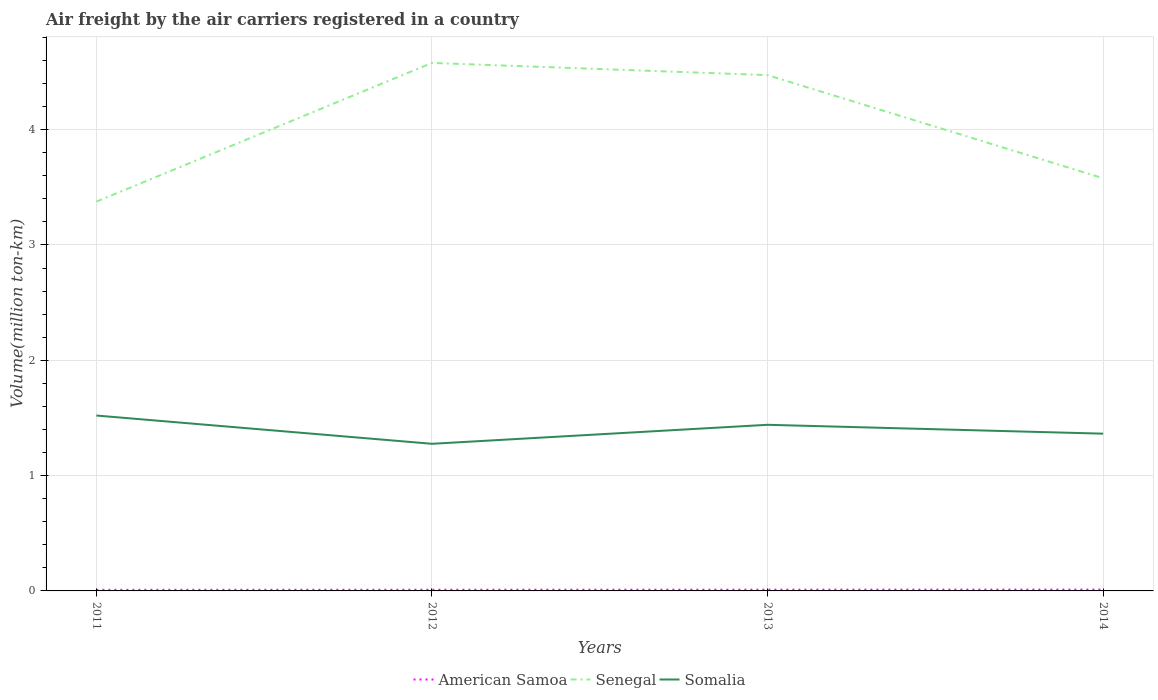How many different coloured lines are there?
Your response must be concise. 3. Does the line corresponding to American Samoa intersect with the line corresponding to Somalia?
Provide a succinct answer. No. Is the number of lines equal to the number of legend labels?
Give a very brief answer. Yes. Across all years, what is the maximum volume of the air carriers in American Samoa?
Offer a very short reply. 0.01. In which year was the volume of the air carriers in American Samoa maximum?
Give a very brief answer. 2011. What is the total volume of the air carriers in Somalia in the graph?
Provide a short and direct response. -0.16. What is the difference between the highest and the second highest volume of the air carriers in American Samoa?
Keep it short and to the point. 0. What is the difference between the highest and the lowest volume of the air carriers in Senegal?
Offer a terse response. 2. How many lines are there?
Provide a succinct answer. 3. How many years are there in the graph?
Provide a succinct answer. 4. Does the graph contain any zero values?
Your answer should be very brief. No. Does the graph contain grids?
Give a very brief answer. Yes. What is the title of the graph?
Ensure brevity in your answer.  Air freight by the air carriers registered in a country. What is the label or title of the X-axis?
Offer a very short reply. Years. What is the label or title of the Y-axis?
Give a very brief answer. Volume(million ton-km). What is the Volume(million ton-km) in American Samoa in 2011?
Give a very brief answer. 0.01. What is the Volume(million ton-km) of Senegal in 2011?
Your answer should be compact. 3.38. What is the Volume(million ton-km) of Somalia in 2011?
Provide a succinct answer. 1.52. What is the Volume(million ton-km) of American Samoa in 2012?
Your answer should be compact. 0.01. What is the Volume(million ton-km) in Senegal in 2012?
Offer a very short reply. 4.58. What is the Volume(million ton-km) of Somalia in 2012?
Make the answer very short. 1.28. What is the Volume(million ton-km) of American Samoa in 2013?
Your response must be concise. 0.01. What is the Volume(million ton-km) of Senegal in 2013?
Give a very brief answer. 4.47. What is the Volume(million ton-km) of Somalia in 2013?
Keep it short and to the point. 1.44. What is the Volume(million ton-km) in American Samoa in 2014?
Make the answer very short. 0.01. What is the Volume(million ton-km) of Senegal in 2014?
Your answer should be very brief. 3.58. What is the Volume(million ton-km) in Somalia in 2014?
Give a very brief answer. 1.36. Across all years, what is the maximum Volume(million ton-km) in American Samoa?
Provide a short and direct response. 0.01. Across all years, what is the maximum Volume(million ton-km) of Senegal?
Provide a short and direct response. 4.58. Across all years, what is the maximum Volume(million ton-km) in Somalia?
Your response must be concise. 1.52. Across all years, what is the minimum Volume(million ton-km) in American Samoa?
Make the answer very short. 0.01. Across all years, what is the minimum Volume(million ton-km) of Senegal?
Offer a terse response. 3.38. Across all years, what is the minimum Volume(million ton-km) of Somalia?
Offer a very short reply. 1.28. What is the total Volume(million ton-km) in American Samoa in the graph?
Ensure brevity in your answer.  0.04. What is the total Volume(million ton-km) in Senegal in the graph?
Make the answer very short. 16.01. What is the total Volume(million ton-km) of Somalia in the graph?
Your answer should be very brief. 5.6. What is the difference between the Volume(million ton-km) in American Samoa in 2011 and that in 2012?
Provide a short and direct response. -0. What is the difference between the Volume(million ton-km) in Senegal in 2011 and that in 2012?
Give a very brief answer. -1.2. What is the difference between the Volume(million ton-km) of Somalia in 2011 and that in 2012?
Your response must be concise. 0.25. What is the difference between the Volume(million ton-km) of American Samoa in 2011 and that in 2013?
Offer a terse response. -0. What is the difference between the Volume(million ton-km) in Senegal in 2011 and that in 2013?
Provide a short and direct response. -1.1. What is the difference between the Volume(million ton-km) in Somalia in 2011 and that in 2013?
Give a very brief answer. 0.08. What is the difference between the Volume(million ton-km) of American Samoa in 2011 and that in 2014?
Your answer should be very brief. -0. What is the difference between the Volume(million ton-km) of Senegal in 2011 and that in 2014?
Your response must be concise. -0.2. What is the difference between the Volume(million ton-km) of Somalia in 2011 and that in 2014?
Give a very brief answer. 0.16. What is the difference between the Volume(million ton-km) in American Samoa in 2012 and that in 2013?
Offer a terse response. -0. What is the difference between the Volume(million ton-km) of Senegal in 2012 and that in 2013?
Make the answer very short. 0.11. What is the difference between the Volume(million ton-km) in Somalia in 2012 and that in 2013?
Your answer should be compact. -0.16. What is the difference between the Volume(million ton-km) of American Samoa in 2012 and that in 2014?
Your response must be concise. -0. What is the difference between the Volume(million ton-km) of Senegal in 2012 and that in 2014?
Offer a very short reply. 1. What is the difference between the Volume(million ton-km) in Somalia in 2012 and that in 2014?
Your answer should be compact. -0.09. What is the difference between the Volume(million ton-km) in American Samoa in 2013 and that in 2014?
Make the answer very short. -0. What is the difference between the Volume(million ton-km) in Senegal in 2013 and that in 2014?
Offer a terse response. 0.89. What is the difference between the Volume(million ton-km) of Somalia in 2013 and that in 2014?
Your answer should be very brief. 0.08. What is the difference between the Volume(million ton-km) of American Samoa in 2011 and the Volume(million ton-km) of Senegal in 2012?
Provide a short and direct response. -4.57. What is the difference between the Volume(million ton-km) of American Samoa in 2011 and the Volume(million ton-km) of Somalia in 2012?
Offer a terse response. -1.27. What is the difference between the Volume(million ton-km) in Senegal in 2011 and the Volume(million ton-km) in Somalia in 2012?
Your answer should be compact. 2.1. What is the difference between the Volume(million ton-km) of American Samoa in 2011 and the Volume(million ton-km) of Senegal in 2013?
Offer a very short reply. -4.46. What is the difference between the Volume(million ton-km) in American Samoa in 2011 and the Volume(million ton-km) in Somalia in 2013?
Make the answer very short. -1.43. What is the difference between the Volume(million ton-km) in Senegal in 2011 and the Volume(million ton-km) in Somalia in 2013?
Your answer should be very brief. 1.94. What is the difference between the Volume(million ton-km) of American Samoa in 2011 and the Volume(million ton-km) of Senegal in 2014?
Your response must be concise. -3.57. What is the difference between the Volume(million ton-km) of American Samoa in 2011 and the Volume(million ton-km) of Somalia in 2014?
Make the answer very short. -1.35. What is the difference between the Volume(million ton-km) of Senegal in 2011 and the Volume(million ton-km) of Somalia in 2014?
Give a very brief answer. 2.01. What is the difference between the Volume(million ton-km) of American Samoa in 2012 and the Volume(million ton-km) of Senegal in 2013?
Offer a terse response. -4.46. What is the difference between the Volume(million ton-km) in American Samoa in 2012 and the Volume(million ton-km) in Somalia in 2013?
Give a very brief answer. -1.43. What is the difference between the Volume(million ton-km) of Senegal in 2012 and the Volume(million ton-km) of Somalia in 2013?
Your answer should be compact. 3.14. What is the difference between the Volume(million ton-km) of American Samoa in 2012 and the Volume(million ton-km) of Senegal in 2014?
Your answer should be compact. -3.57. What is the difference between the Volume(million ton-km) of American Samoa in 2012 and the Volume(million ton-km) of Somalia in 2014?
Provide a short and direct response. -1.35. What is the difference between the Volume(million ton-km) of Senegal in 2012 and the Volume(million ton-km) of Somalia in 2014?
Offer a terse response. 3.22. What is the difference between the Volume(million ton-km) of American Samoa in 2013 and the Volume(million ton-km) of Senegal in 2014?
Keep it short and to the point. -3.57. What is the difference between the Volume(million ton-km) in American Samoa in 2013 and the Volume(million ton-km) in Somalia in 2014?
Keep it short and to the point. -1.35. What is the difference between the Volume(million ton-km) in Senegal in 2013 and the Volume(million ton-km) in Somalia in 2014?
Keep it short and to the point. 3.11. What is the average Volume(million ton-km) of American Samoa per year?
Make the answer very short. 0.01. What is the average Volume(million ton-km) of Senegal per year?
Keep it short and to the point. 4. What is the average Volume(million ton-km) of Somalia per year?
Keep it short and to the point. 1.4. In the year 2011, what is the difference between the Volume(million ton-km) in American Samoa and Volume(million ton-km) in Senegal?
Offer a terse response. -3.37. In the year 2011, what is the difference between the Volume(million ton-km) in American Samoa and Volume(million ton-km) in Somalia?
Provide a short and direct response. -1.51. In the year 2011, what is the difference between the Volume(million ton-km) in Senegal and Volume(million ton-km) in Somalia?
Offer a terse response. 1.85. In the year 2012, what is the difference between the Volume(million ton-km) of American Samoa and Volume(million ton-km) of Senegal?
Give a very brief answer. -4.57. In the year 2012, what is the difference between the Volume(million ton-km) of American Samoa and Volume(million ton-km) of Somalia?
Your answer should be compact. -1.27. In the year 2012, what is the difference between the Volume(million ton-km) in Senegal and Volume(million ton-km) in Somalia?
Provide a succinct answer. 3.3. In the year 2013, what is the difference between the Volume(million ton-km) of American Samoa and Volume(million ton-km) of Senegal?
Keep it short and to the point. -4.46. In the year 2013, what is the difference between the Volume(million ton-km) in American Samoa and Volume(million ton-km) in Somalia?
Provide a short and direct response. -1.43. In the year 2013, what is the difference between the Volume(million ton-km) in Senegal and Volume(million ton-km) in Somalia?
Your answer should be compact. 3.03. In the year 2014, what is the difference between the Volume(million ton-km) of American Samoa and Volume(million ton-km) of Senegal?
Offer a very short reply. -3.57. In the year 2014, what is the difference between the Volume(million ton-km) of American Samoa and Volume(million ton-km) of Somalia?
Make the answer very short. -1.35. In the year 2014, what is the difference between the Volume(million ton-km) in Senegal and Volume(million ton-km) in Somalia?
Ensure brevity in your answer.  2.21. What is the ratio of the Volume(million ton-km) of American Samoa in 2011 to that in 2012?
Keep it short and to the point. 0.9. What is the ratio of the Volume(million ton-km) of Senegal in 2011 to that in 2012?
Provide a succinct answer. 0.74. What is the ratio of the Volume(million ton-km) of Somalia in 2011 to that in 2012?
Offer a terse response. 1.19. What is the ratio of the Volume(million ton-km) of American Samoa in 2011 to that in 2013?
Keep it short and to the point. 0.87. What is the ratio of the Volume(million ton-km) of Senegal in 2011 to that in 2013?
Keep it short and to the point. 0.75. What is the ratio of the Volume(million ton-km) in Somalia in 2011 to that in 2013?
Provide a short and direct response. 1.06. What is the ratio of the Volume(million ton-km) in American Samoa in 2011 to that in 2014?
Offer a very short reply. 0.82. What is the ratio of the Volume(million ton-km) in Senegal in 2011 to that in 2014?
Your answer should be compact. 0.94. What is the ratio of the Volume(million ton-km) in Somalia in 2011 to that in 2014?
Ensure brevity in your answer.  1.12. What is the ratio of the Volume(million ton-km) in American Samoa in 2012 to that in 2013?
Provide a succinct answer. 0.97. What is the ratio of the Volume(million ton-km) of Senegal in 2012 to that in 2013?
Give a very brief answer. 1.02. What is the ratio of the Volume(million ton-km) in Somalia in 2012 to that in 2013?
Your response must be concise. 0.89. What is the ratio of the Volume(million ton-km) of American Samoa in 2012 to that in 2014?
Your answer should be very brief. 0.91. What is the ratio of the Volume(million ton-km) in Senegal in 2012 to that in 2014?
Give a very brief answer. 1.28. What is the ratio of the Volume(million ton-km) in Somalia in 2012 to that in 2014?
Ensure brevity in your answer.  0.94. What is the ratio of the Volume(million ton-km) in American Samoa in 2013 to that in 2014?
Your response must be concise. 0.94. What is the ratio of the Volume(million ton-km) of Senegal in 2013 to that in 2014?
Your answer should be very brief. 1.25. What is the ratio of the Volume(million ton-km) of Somalia in 2013 to that in 2014?
Provide a succinct answer. 1.06. What is the difference between the highest and the second highest Volume(million ton-km) in American Samoa?
Your answer should be compact. 0. What is the difference between the highest and the second highest Volume(million ton-km) in Senegal?
Make the answer very short. 0.11. What is the difference between the highest and the second highest Volume(million ton-km) in Somalia?
Offer a very short reply. 0.08. What is the difference between the highest and the lowest Volume(million ton-km) of American Samoa?
Ensure brevity in your answer.  0. What is the difference between the highest and the lowest Volume(million ton-km) in Senegal?
Provide a succinct answer. 1.2. What is the difference between the highest and the lowest Volume(million ton-km) of Somalia?
Ensure brevity in your answer.  0.25. 